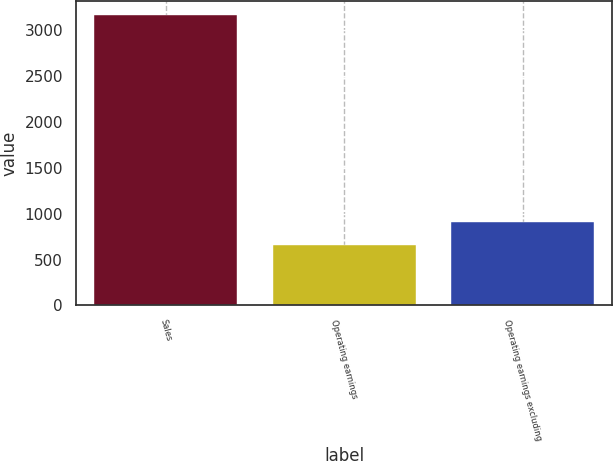<chart> <loc_0><loc_0><loc_500><loc_500><bar_chart><fcel>Sales<fcel>Operating earnings<fcel>Operating earnings excluding<nl><fcel>3159<fcel>660<fcel>909.9<nl></chart> 